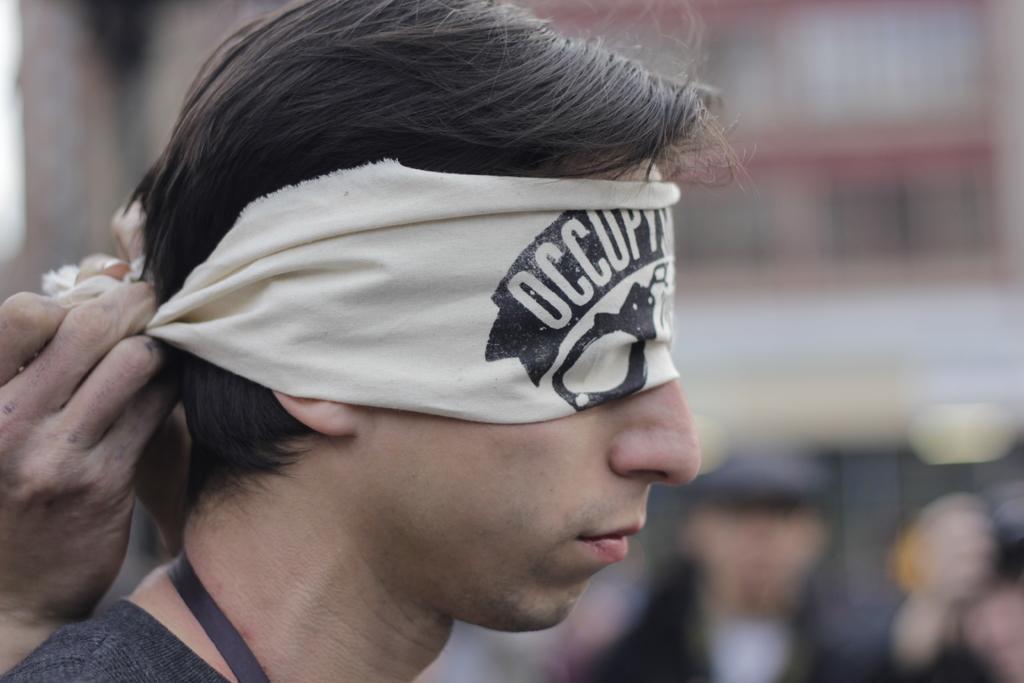Can you describe this image briefly? In the center of the image is a person his eyes are closed with a blindfold. There is a person hand to the left side of the image. The background of the image is blurry. 